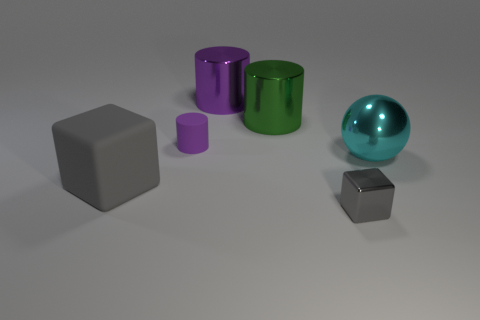Subtract all yellow cubes. How many purple cylinders are left? 2 Subtract all purple cylinders. How many cylinders are left? 1 Add 3 metal cylinders. How many objects exist? 9 Subtract all yellow cylinders. Subtract all cyan spheres. How many cylinders are left? 3 Subtract all cubes. How many objects are left? 4 Add 5 small purple rubber cubes. How many small purple rubber cubes exist? 5 Subtract 0 red cylinders. How many objects are left? 6 Subtract all tiny objects. Subtract all big purple objects. How many objects are left? 3 Add 5 purple cylinders. How many purple cylinders are left? 7 